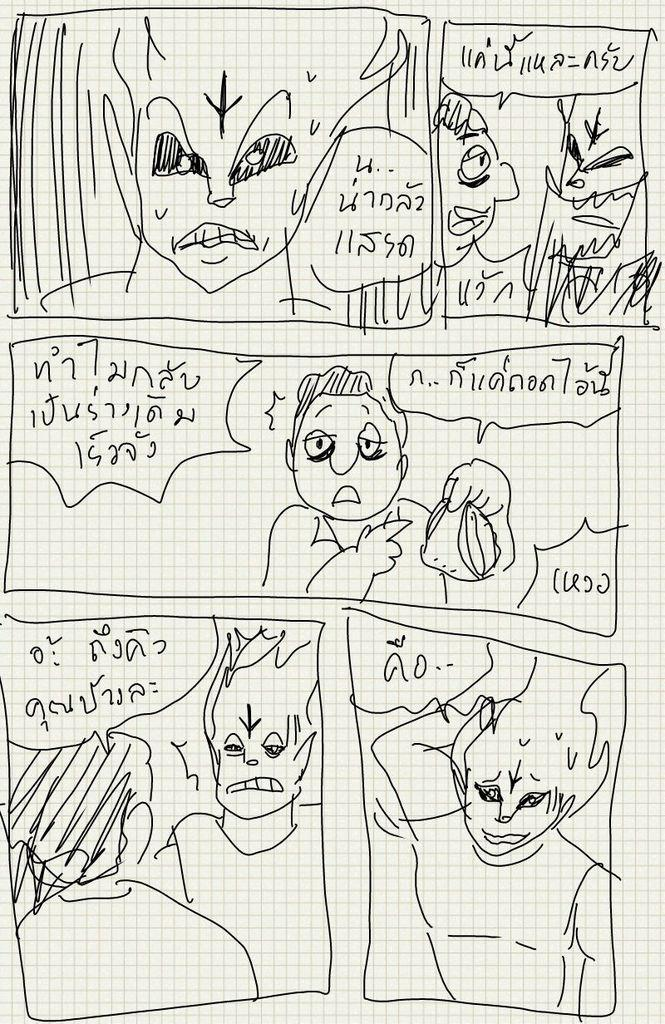What type of content is present in the image? The image contains pictures of people and text. Can you describe the paper at the bottom of the image? Yes, there is a paper at the bottom of the image. What might the text in the image be communicating? The text in the image could be conveying information or a message related to the pictures of people. How many cacti are visible in the image? There are no cacti present in the image. Is the image taken in a quiet environment? The image does not provide any information about the noise level in the environment where it was taken. 